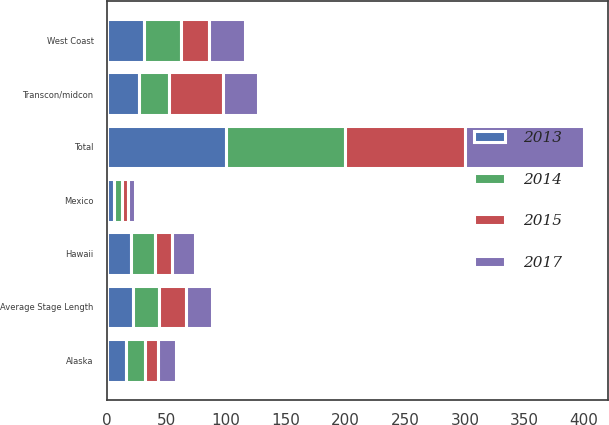Convert chart. <chart><loc_0><loc_0><loc_500><loc_500><stacked_bar_chart><ecel><fcel>West Coast<fcel>Transcon/midcon<fcel>Hawaii<fcel>Alaska<fcel>Mexico<fcel>Total<fcel>Average Stage Length<nl><fcel>2015<fcel>24<fcel>45<fcel>15<fcel>11<fcel>5<fcel>100<fcel>22<nl><fcel>2017<fcel>30<fcel>30<fcel>19<fcel>15<fcel>6<fcel>100<fcel>22<nl><fcel>2013<fcel>31<fcel>27<fcel>20<fcel>16<fcel>6<fcel>100<fcel>22<nl><fcel>2014<fcel>31<fcel>25<fcel>20<fcel>16<fcel>7<fcel>100<fcel>22<nl></chart> 